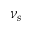<formula> <loc_0><loc_0><loc_500><loc_500>\nu _ { s }</formula> 